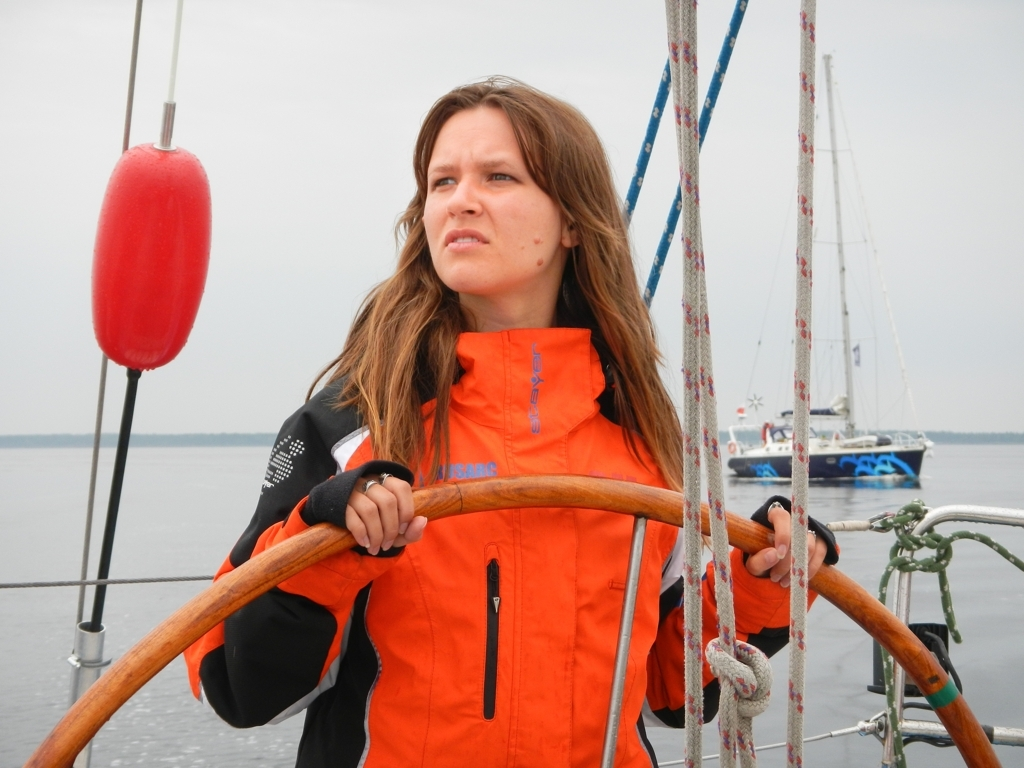Can you describe the weather conditions observed in the image? The weather in the image appears overcast with a predominantly grey sky, indicating a cloudy day. The lack of harsh shadows on the person's face and surroundings further suggest an even, diffused lighting, which is common in such cloudy conditions. These factors combined with the calm water surface hint at tranquility with no immediate signs of inclement weather. 